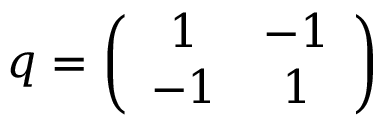<formula> <loc_0><loc_0><loc_500><loc_500>q = \left ( \begin{array} { c c } { 1 } & { - 1 } \\ { - 1 } & { 1 } \end{array} \right )</formula> 